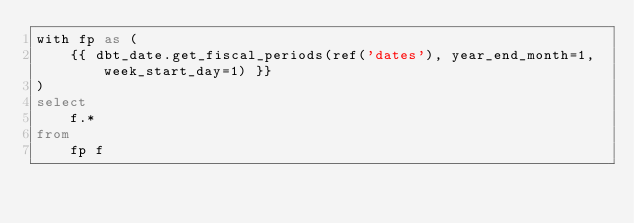Convert code to text. <code><loc_0><loc_0><loc_500><loc_500><_SQL_>with fp as (
    {{ dbt_date.get_fiscal_periods(ref('dates'), year_end_month=1, week_start_day=1) }}
)
select
    f.*
from
    fp f</code> 